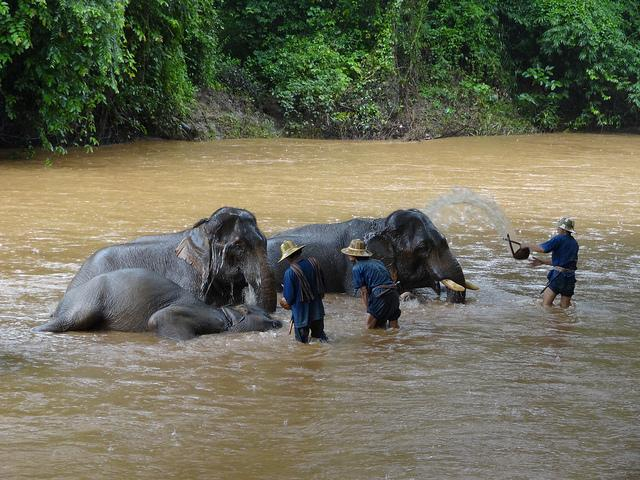Why is the water brown?

Choices:
A) sand
B) leeches
C) dirt
D) fish dirt 